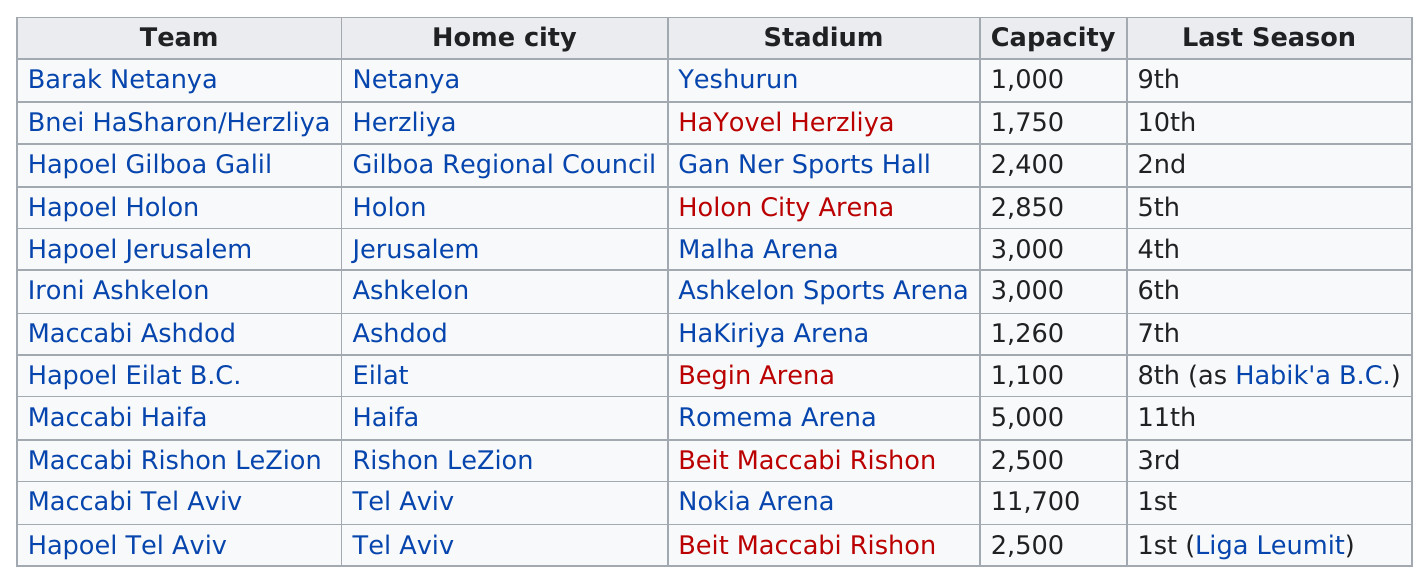Outline some significant characteristics in this image. With the opening of Romema Arena, the stadium sequence has been completed, marking the end of the arena phase and the beginning of a new era for sports and entertainment venues. The Nokia Arena has a larger capacity than the Ramat-Aranya Stadium, also known as Romema Arena. The Holon City Arena has a maximum capacity of 2,850 people for attending a game. The question asks whether Yeshurun or Holon City holds more people. The answer is that Holon City Arena holds more people. The Nokia Arena is the stadium that can seat the most people. 